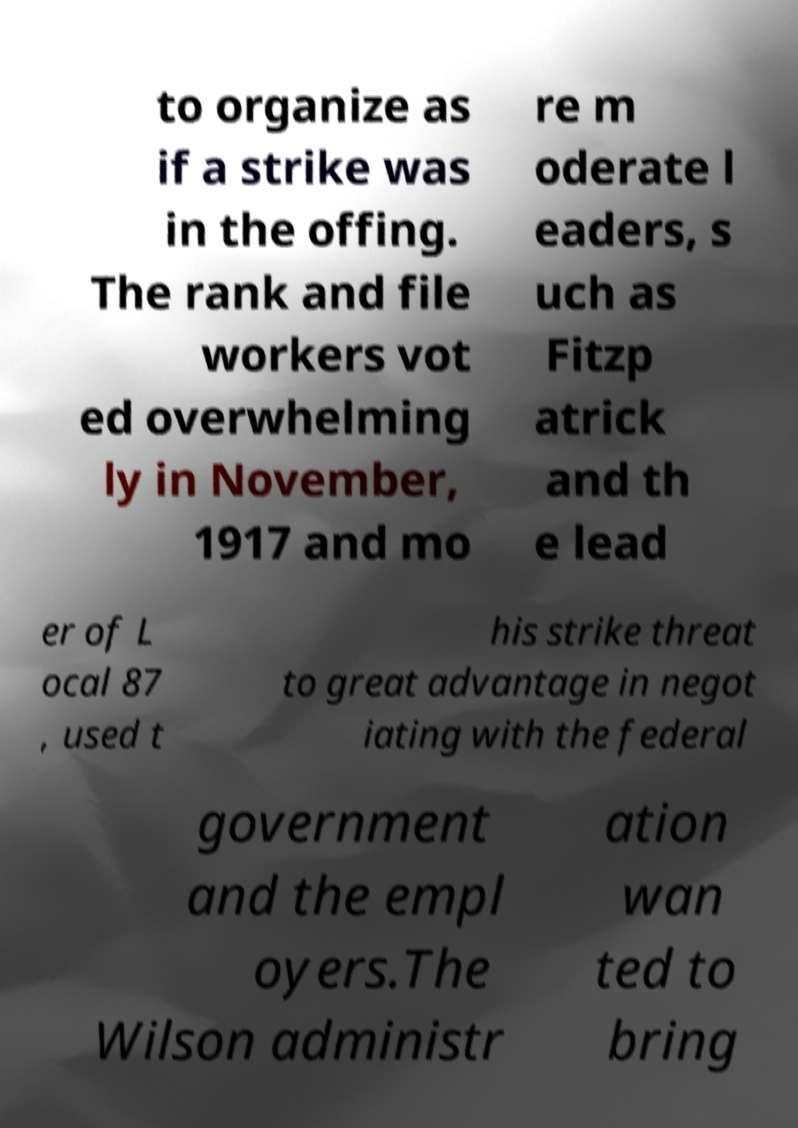Could you assist in decoding the text presented in this image and type it out clearly? to organize as if a strike was in the offing. The rank and file workers vot ed overwhelming ly in November, 1917 and mo re m oderate l eaders, s uch as Fitzp atrick and th e lead er of L ocal 87 , used t his strike threat to great advantage in negot iating with the federal government and the empl oyers.The Wilson administr ation wan ted to bring 